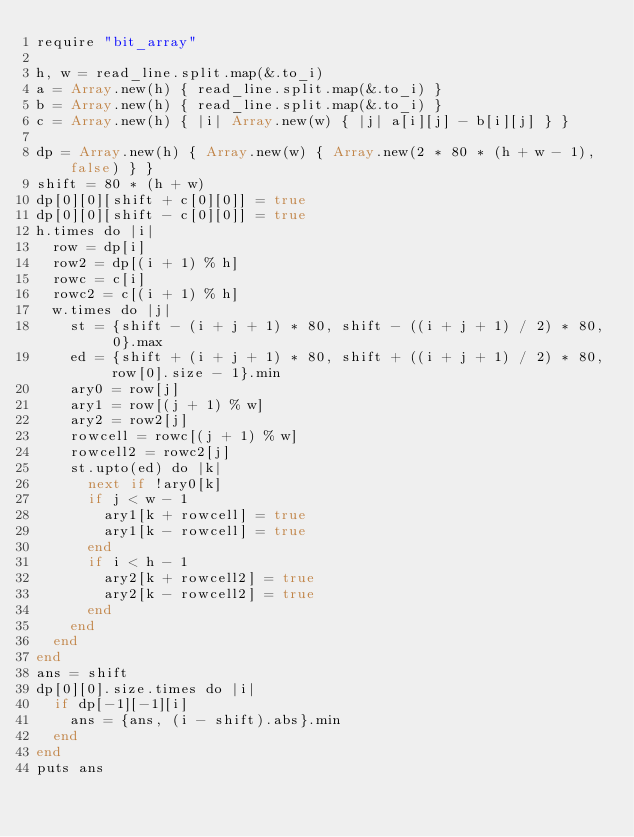<code> <loc_0><loc_0><loc_500><loc_500><_Crystal_>require "bit_array"

h, w = read_line.split.map(&.to_i)
a = Array.new(h) { read_line.split.map(&.to_i) }
b = Array.new(h) { read_line.split.map(&.to_i) }
c = Array.new(h) { |i| Array.new(w) { |j| a[i][j] - b[i][j] } }

dp = Array.new(h) { Array.new(w) { Array.new(2 * 80 * (h + w - 1), false) } }
shift = 80 * (h + w)
dp[0][0][shift + c[0][0]] = true
dp[0][0][shift - c[0][0]] = true
h.times do |i|
  row = dp[i]
  row2 = dp[(i + 1) % h]
  rowc = c[i]
  rowc2 = c[(i + 1) % h]
  w.times do |j|
    st = {shift - (i + j + 1) * 80, shift - ((i + j + 1) / 2) * 80, 0}.max
    ed = {shift + (i + j + 1) * 80, shift + ((i + j + 1) / 2) * 80, row[0].size - 1}.min
    ary0 = row[j]
    ary1 = row[(j + 1) % w]
    ary2 = row2[j]
    rowcell = rowc[(j + 1) % w]
    rowcell2 = rowc2[j]
    st.upto(ed) do |k|
      next if !ary0[k]
      if j < w - 1
        ary1[k + rowcell] = true
        ary1[k - rowcell] = true
      end
      if i < h - 1
        ary2[k + rowcell2] = true
        ary2[k - rowcell2] = true
      end
    end
  end
end
ans = shift
dp[0][0].size.times do |i|
  if dp[-1][-1][i]
    ans = {ans, (i - shift).abs}.min
  end
end
puts ans
</code> 